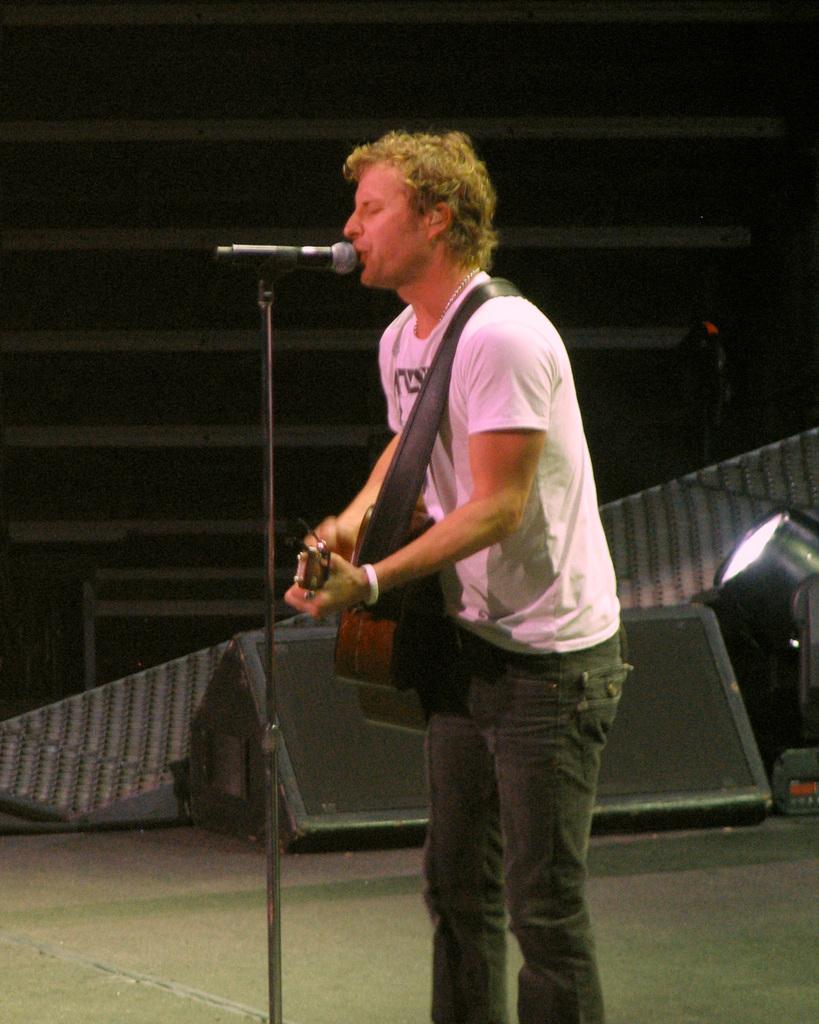Please provide a concise description of this image. In this image we can see there is a person standing and playing a guitar and singing into a microphone. And at the back there is a board and light. And the object looks like a wall. 